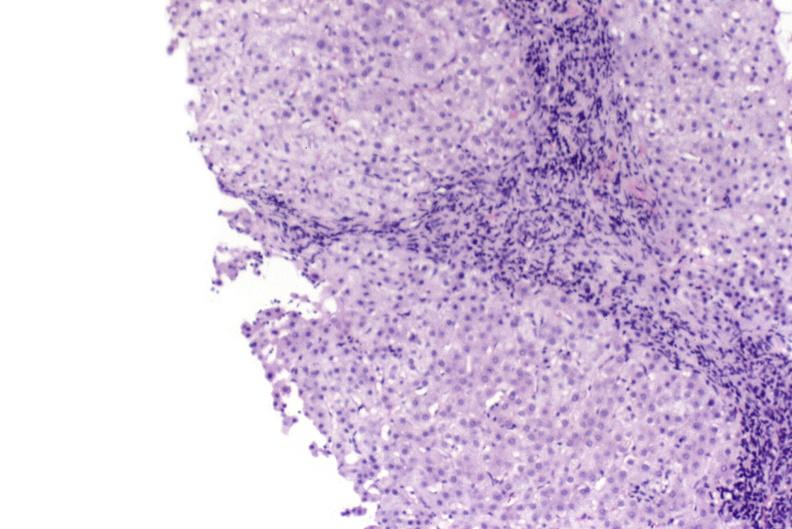s hepatobiliary present?
Answer the question using a single word or phrase. Yes 